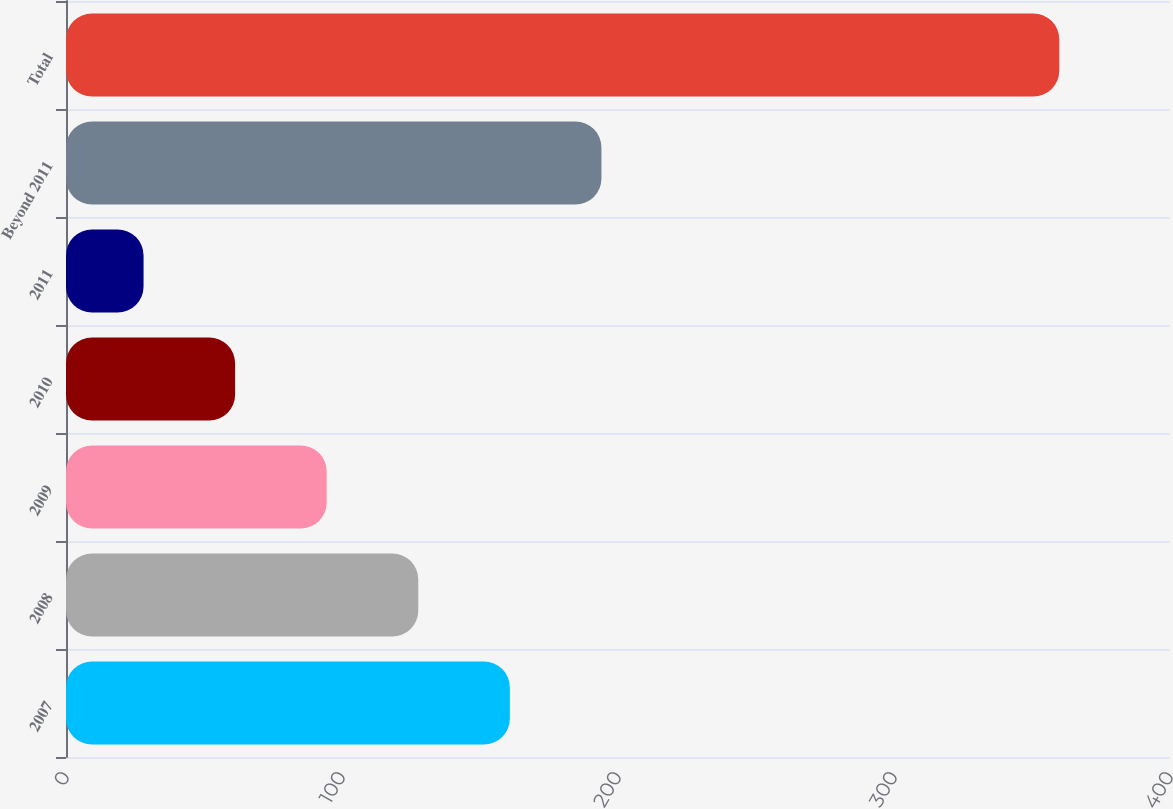Convert chart to OTSL. <chart><loc_0><loc_0><loc_500><loc_500><bar_chart><fcel>2007<fcel>2008<fcel>2009<fcel>2010<fcel>2011<fcel>Beyond 2011<fcel>Total<nl><fcel>160.82<fcel>127.64<fcel>94.46<fcel>61.28<fcel>28.1<fcel>194<fcel>359.9<nl></chart> 